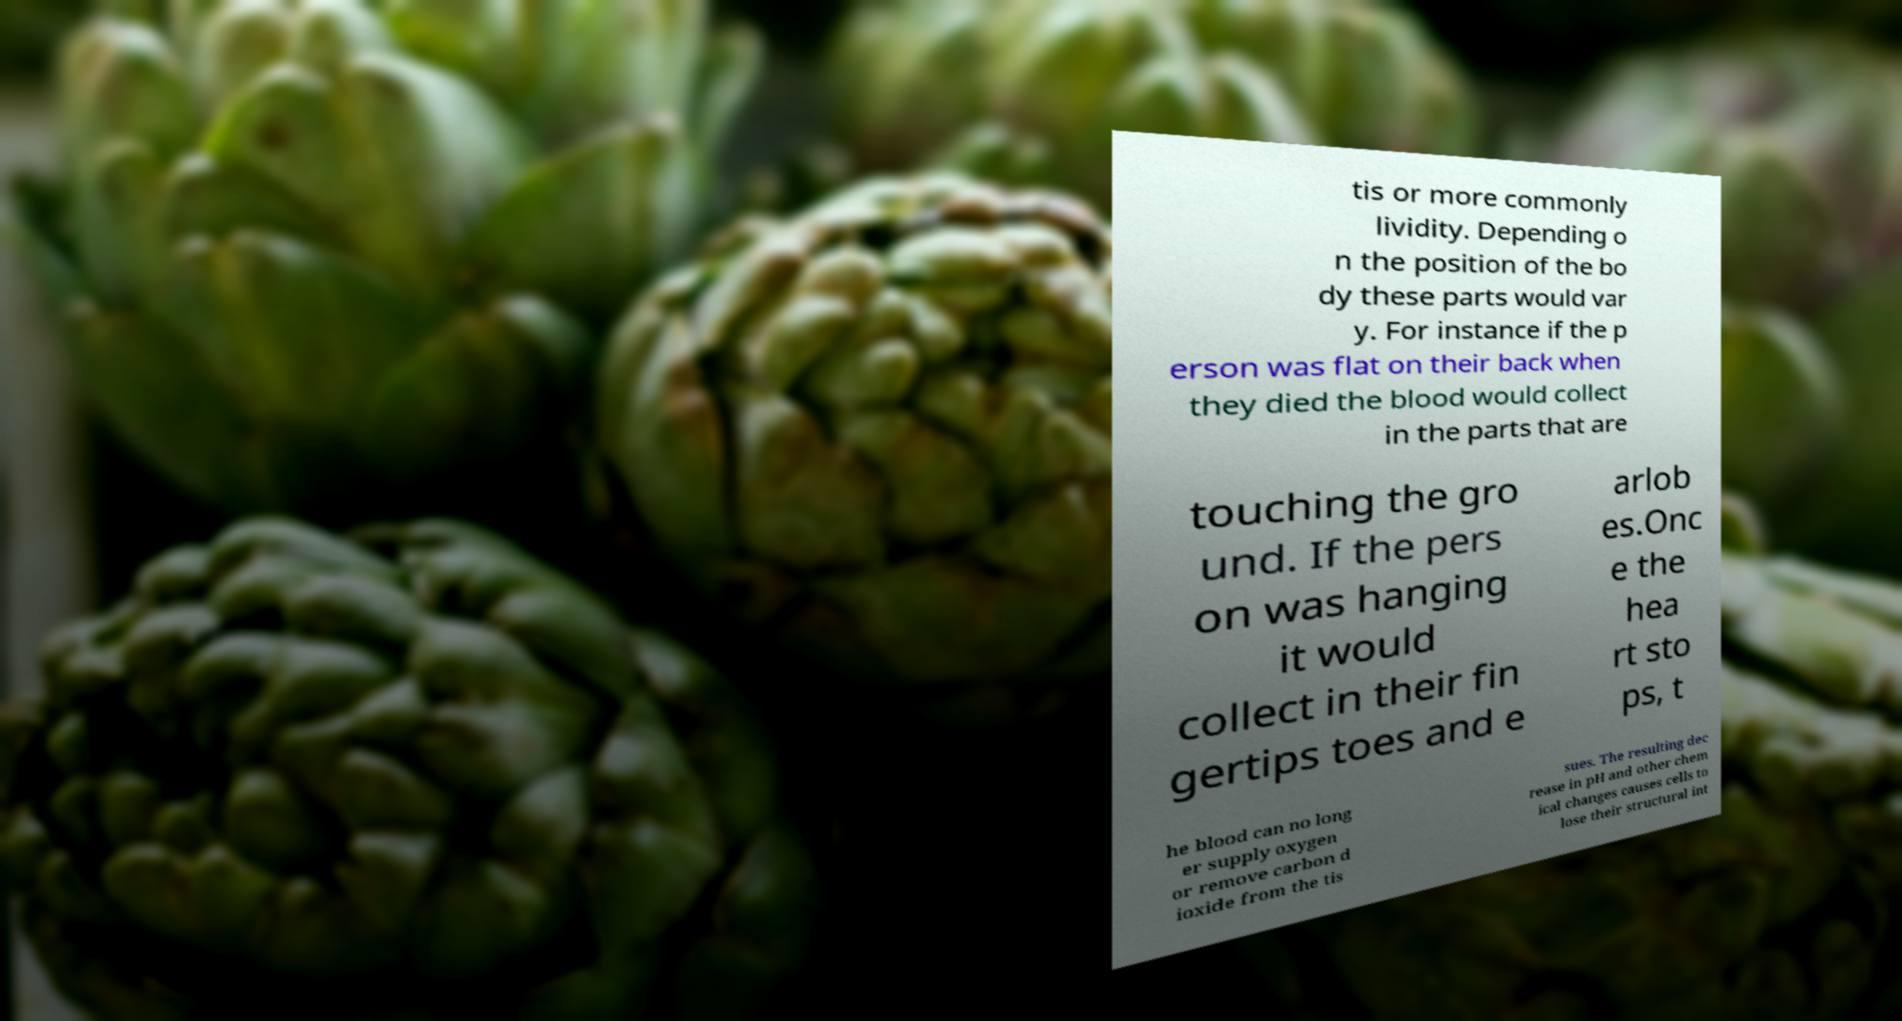Please read and relay the text visible in this image. What does it say? tis or more commonly lividity. Depending o n the position of the bo dy these parts would var y. For instance if the p erson was flat on their back when they died the blood would collect in the parts that are touching the gro und. If the pers on was hanging it would collect in their fin gertips toes and e arlob es.Onc e the hea rt sto ps, t he blood can no long er supply oxygen or remove carbon d ioxide from the tis sues. The resulting dec rease in pH and other chem ical changes causes cells to lose their structural int 